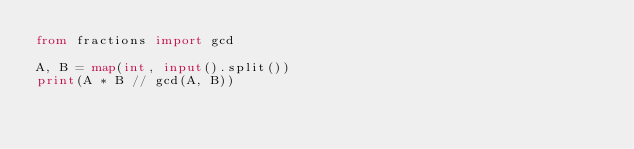<code> <loc_0><loc_0><loc_500><loc_500><_Python_>from fractions import gcd

A, B = map(int, input().split())
print(A * B // gcd(A, B))</code> 